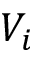<formula> <loc_0><loc_0><loc_500><loc_500>V _ { i }</formula> 